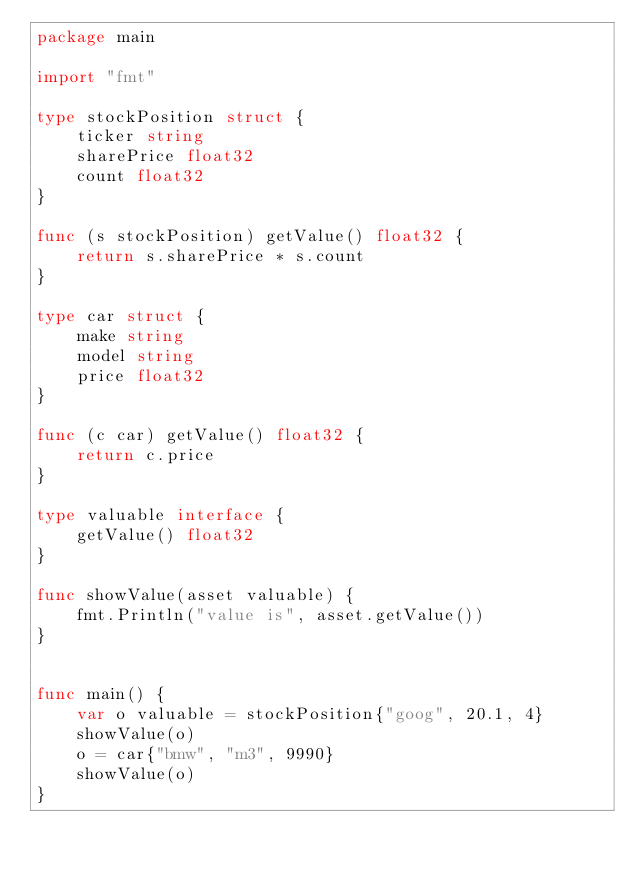Convert code to text. <code><loc_0><loc_0><loc_500><loc_500><_Go_>package main

import "fmt"

type stockPosition struct {
	ticker string
	sharePrice float32
	count float32
}

func (s stockPosition) getValue() float32 {
	return s.sharePrice * s.count
}

type car struct {
	make string
	model string
	price float32
}

func (c car) getValue() float32 {
	return c.price
}

type valuable interface {
	getValue() float32
}

func showValue(asset valuable) {
	fmt.Println("value is", asset.getValue())
}


func main() {
	var o valuable = stockPosition{"goog", 20.1, 4}
	showValue(o)
	o = car{"bmw", "m3", 9990}
	showValue(o)
}
</code> 